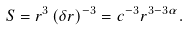Convert formula to latex. <formula><loc_0><loc_0><loc_500><loc_500>S = r ^ { 3 } \left ( \delta r \right ) ^ { - 3 } = c ^ { - 3 } r ^ { 3 - 3 \alpha } .</formula> 